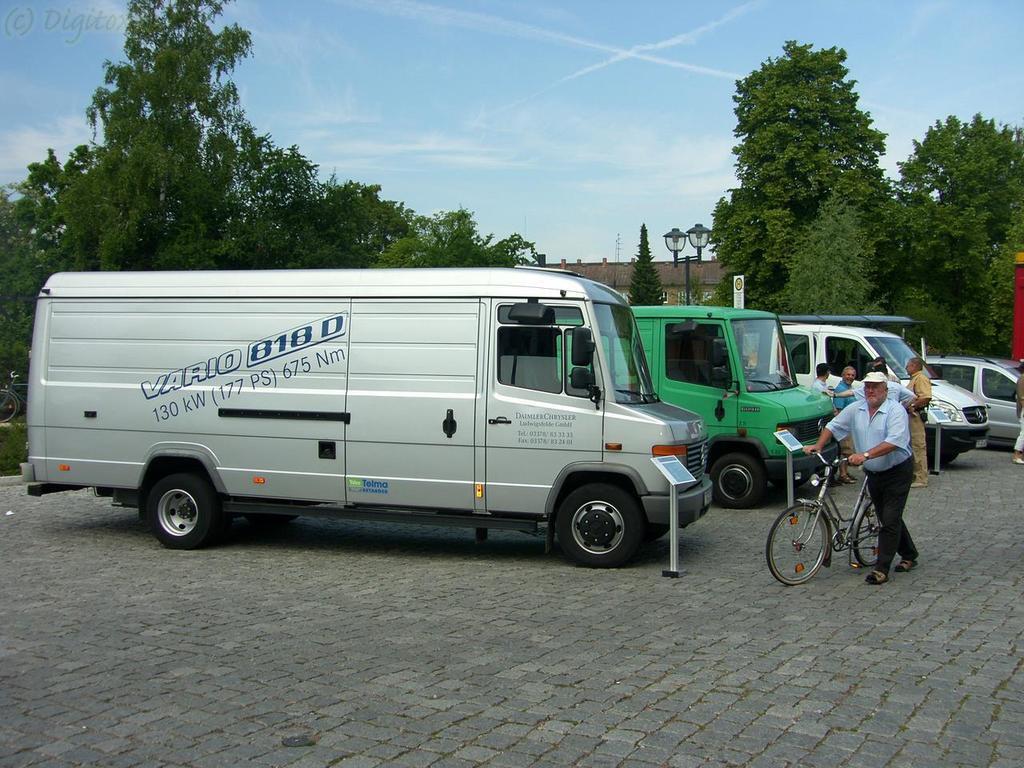Please provide a concise description of this image. In this image there are vehicles, persons and there are trees and there is a building, there are poles and there is a man holding a bicycle and walking and the sky is cloudy. 